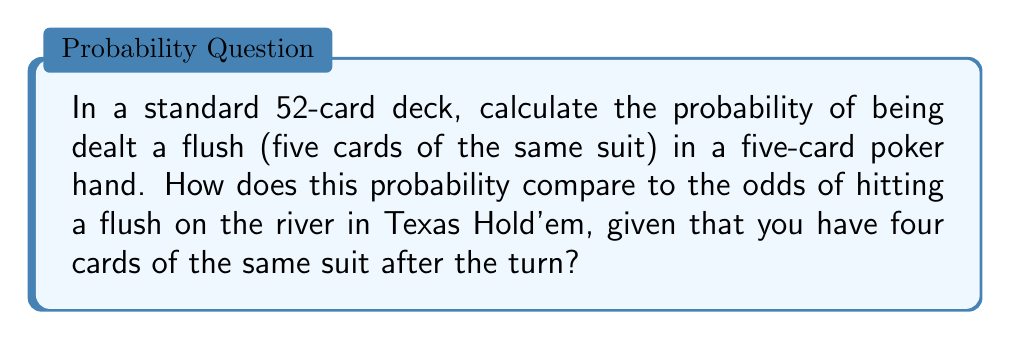Give your solution to this math problem. Let's break this down step by step:

1) Probability of a flush in a five-card poker hand:

   a) There are $\binom{52}{5} = 2,598,960$ possible five-card hands.
   
   b) To count flushes, we choose one of the 4 suits, then choose 5 cards from the 13 cards of that suit:
      $4 \times \binom{13}{5} = 4 \times 1,287 = 5,148$ flush hands.
   
   c) Probability = $\frac{5,148}{2,598,960} = \frac{1}{504} \approx 0.00198$ or about 0.198%

2) Probability of hitting a flush on the river in Texas Hold'em:

   a) After the turn, you have 4 cards of the same suit. You need one more card of that suit on the river.
   
   b) There are 9 cards of your suit left in the deck (13 - 4 you see).
   
   c) There are 47 unseen cards total (52 - 5 cards you see).
   
   d) Probability = $\frac{9}{47} \approx 0.1915$ or about 19.15%

Comparing these probabilities:

$$\frac{0.1915}{0.00198} \approx 96.72$$

This means you're about 96.72 times more likely to hit your flush on the river in the Texas Hold'em scenario compared to being dealt a flush in a five-card draw.
Answer: The probability of being dealt a flush in a five-card poker hand is $\frac{1}{504} \approx 0.198\%$. The probability of hitting a flush on the river in Texas Hold'em, given four cards of the same suit after the turn, is $\frac{9}{47} \approx 19.15\%$. The Texas Hold'em scenario is approximately 96.72 times more likely to occur. 